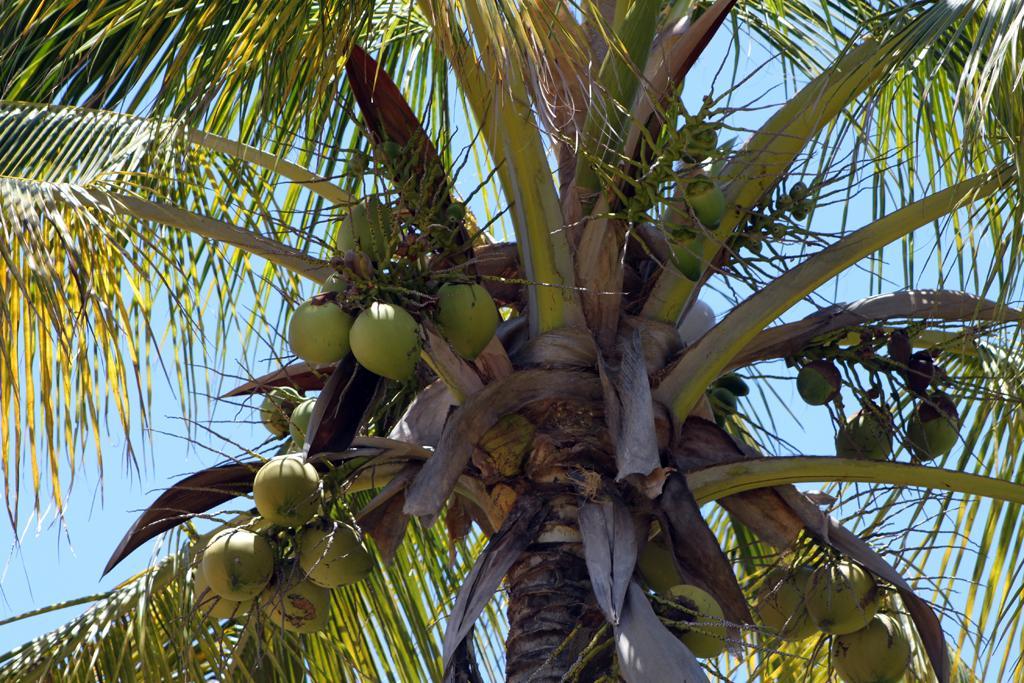How would you summarize this image in a sentence or two? In this image there is a tree with coconuts, and in the background there is sky. 